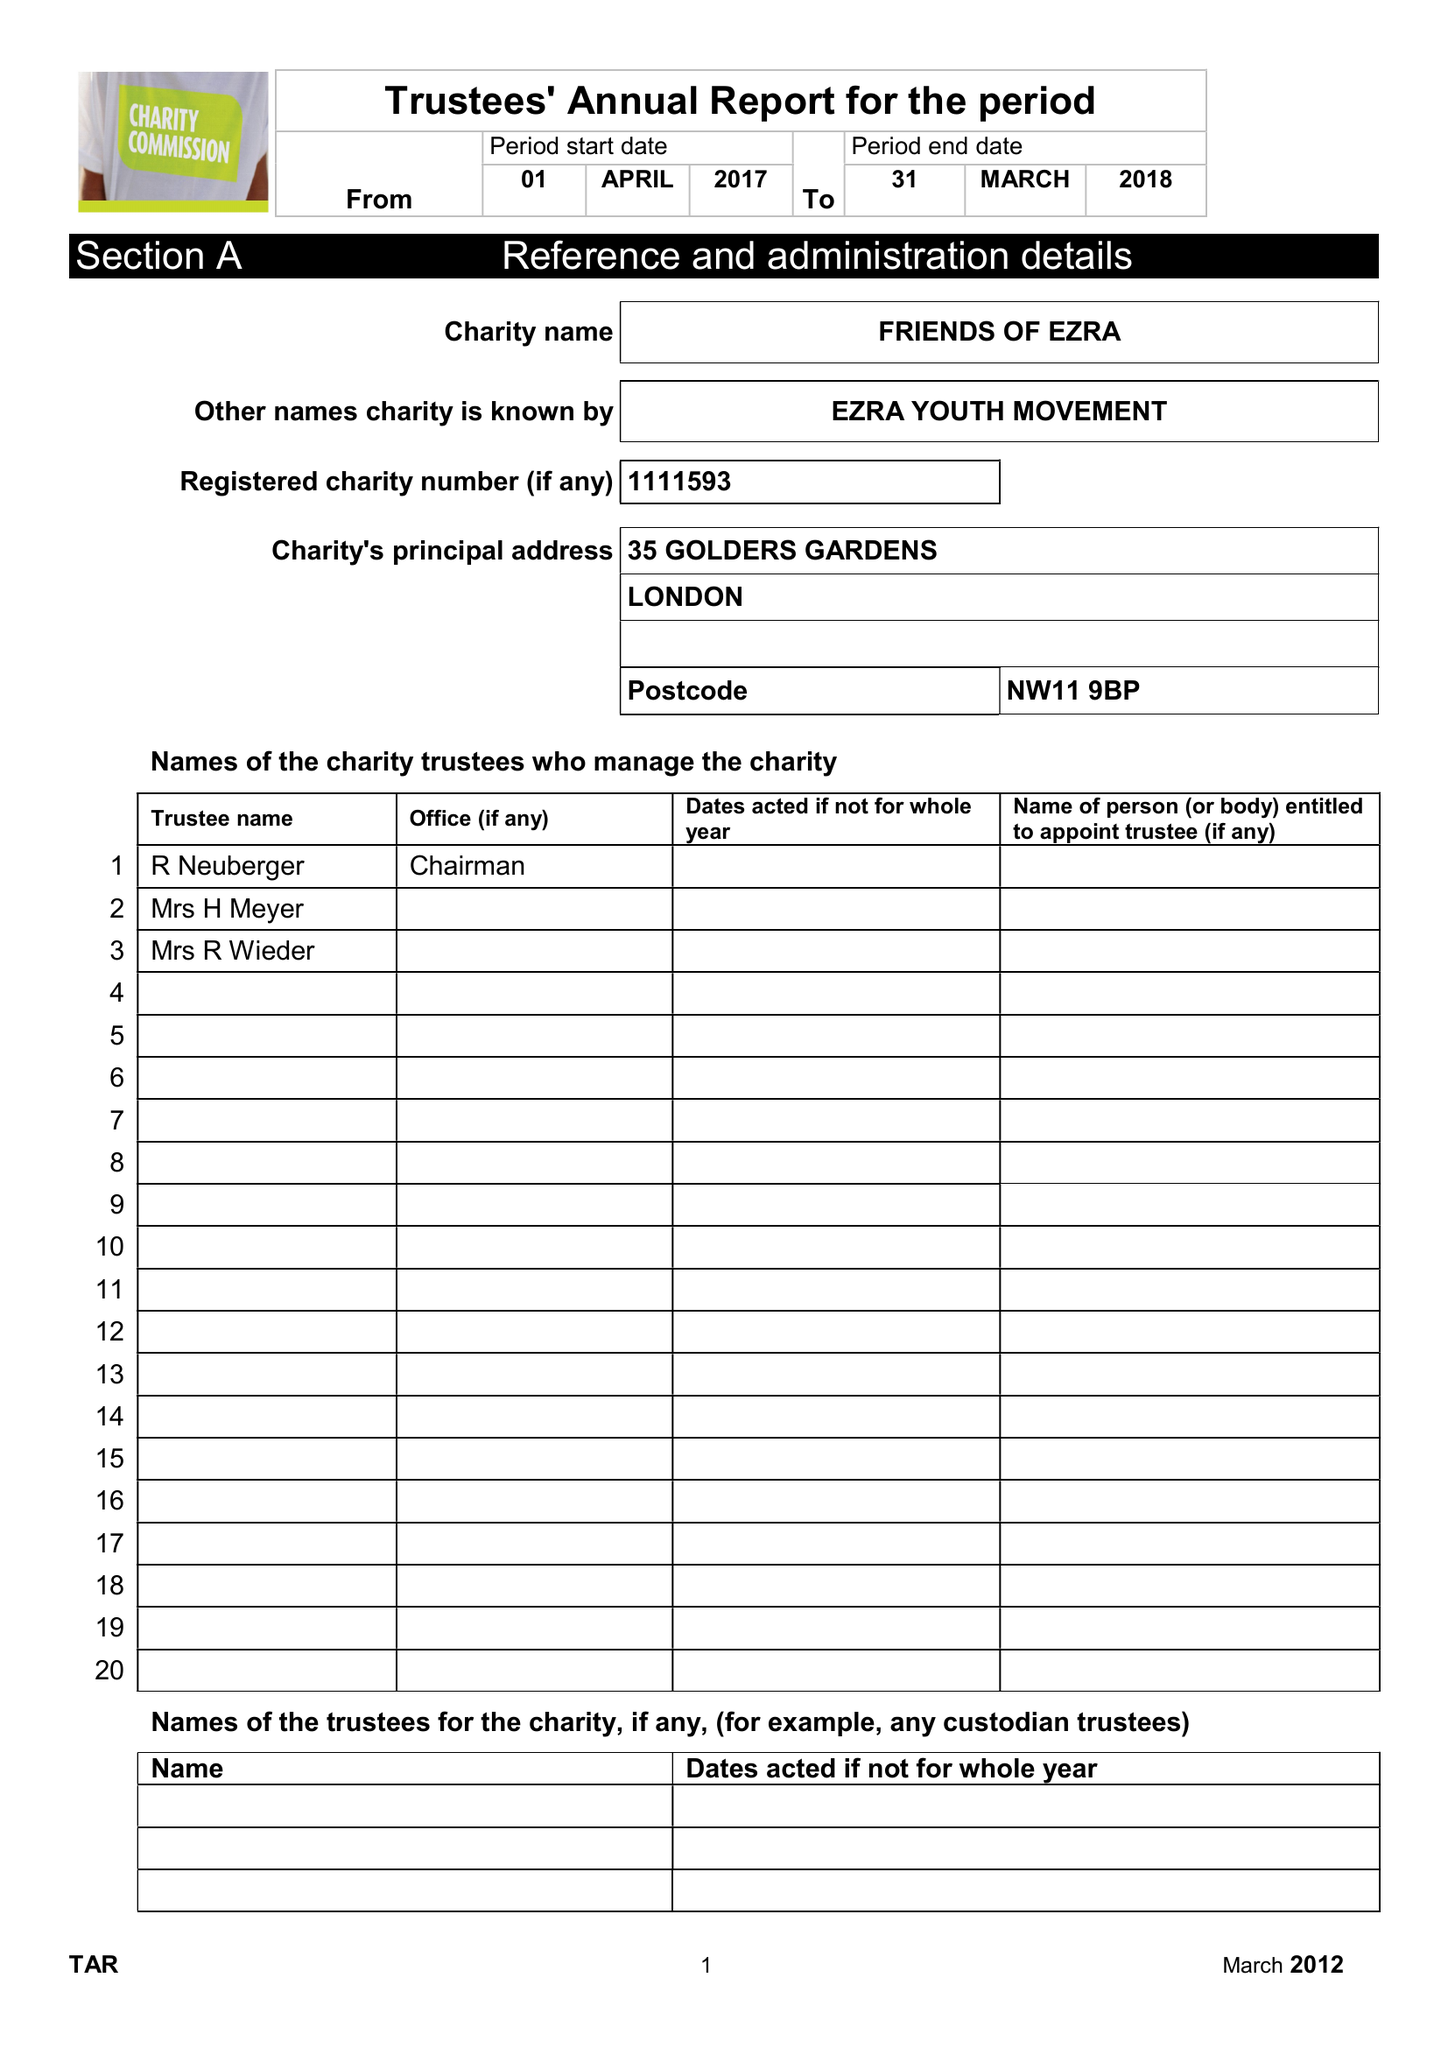What is the value for the address__postcode?
Answer the question using a single word or phrase. NW11 9BP 